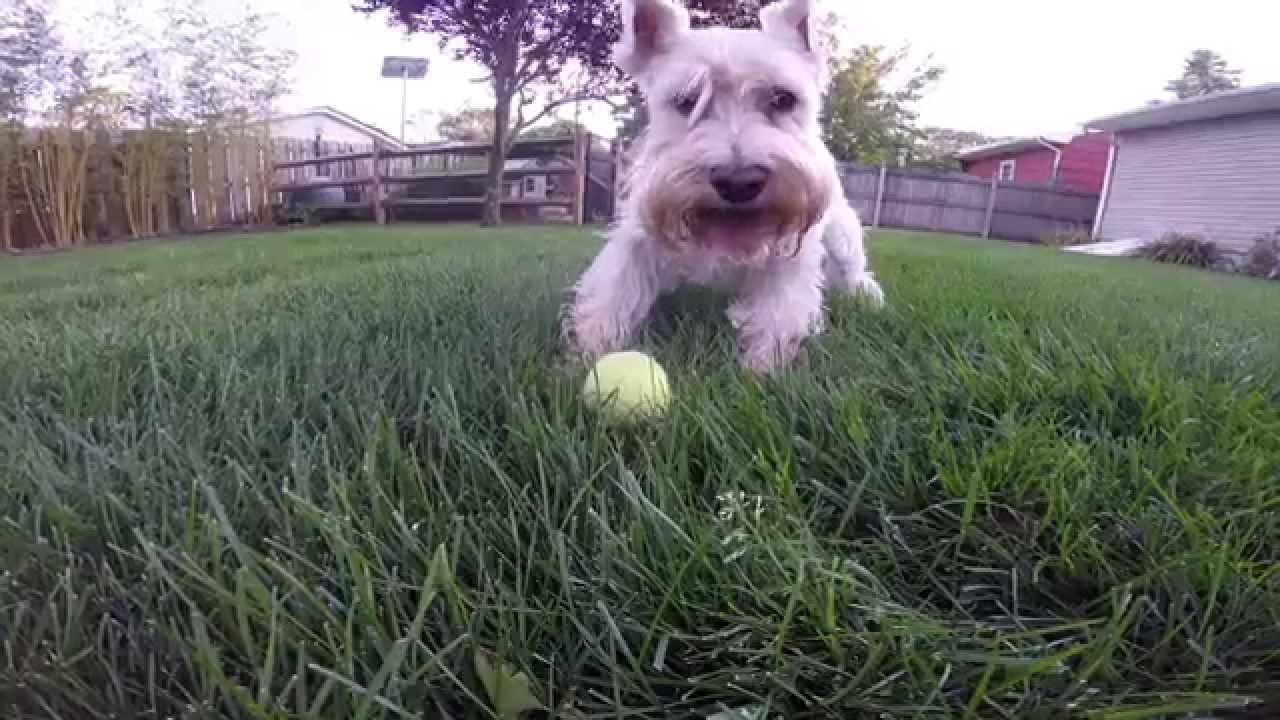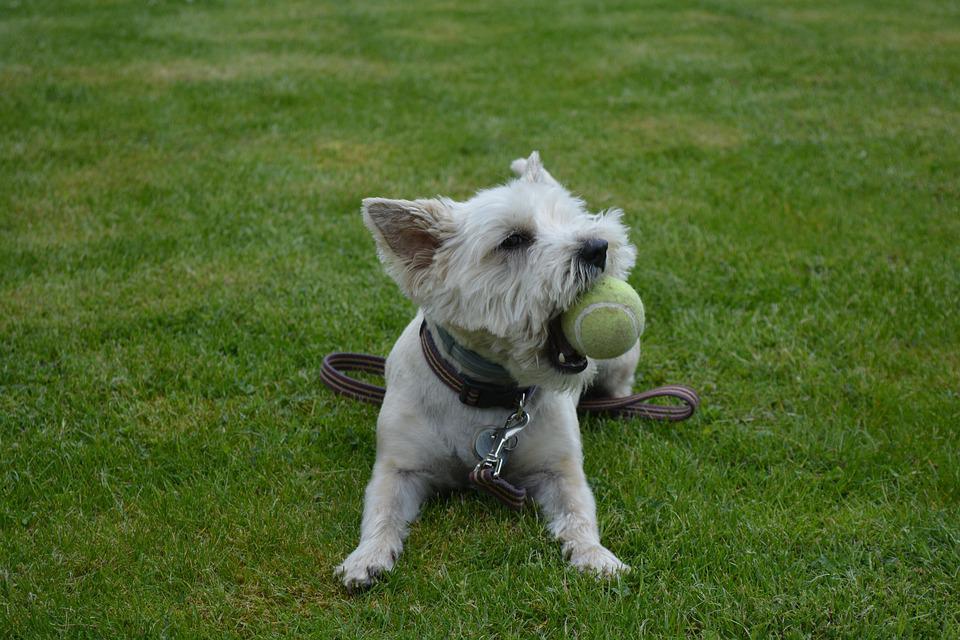The first image is the image on the left, the second image is the image on the right. Considering the images on both sides, is "A ball is in the grass in front of a dog in one image." valid? Answer yes or no. Yes. The first image is the image on the left, the second image is the image on the right. For the images shown, is this caption "Two dogs are playing in the grass in at least one of the images." true? Answer yes or no. No. 